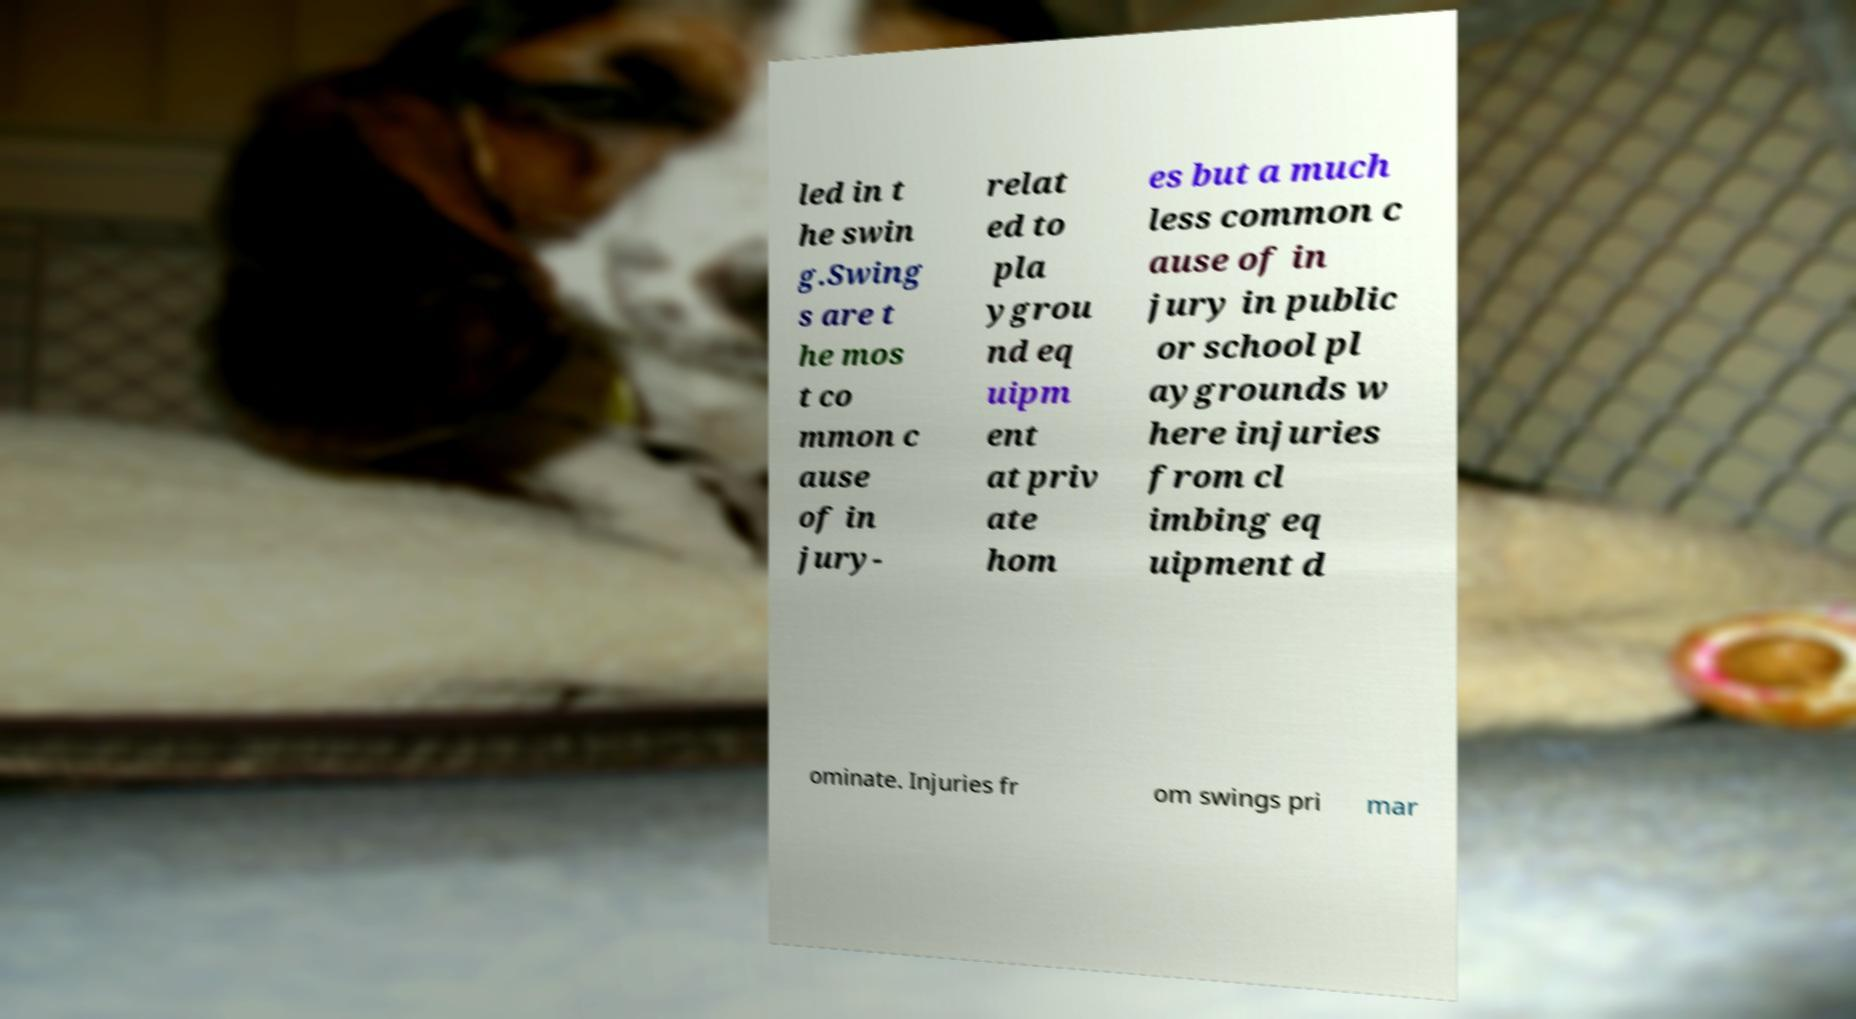For documentation purposes, I need the text within this image transcribed. Could you provide that? led in t he swin g.Swing s are t he mos t co mmon c ause of in jury- relat ed to pla ygrou nd eq uipm ent at priv ate hom es but a much less common c ause of in jury in public or school pl aygrounds w here injuries from cl imbing eq uipment d ominate. Injuries fr om swings pri mar 